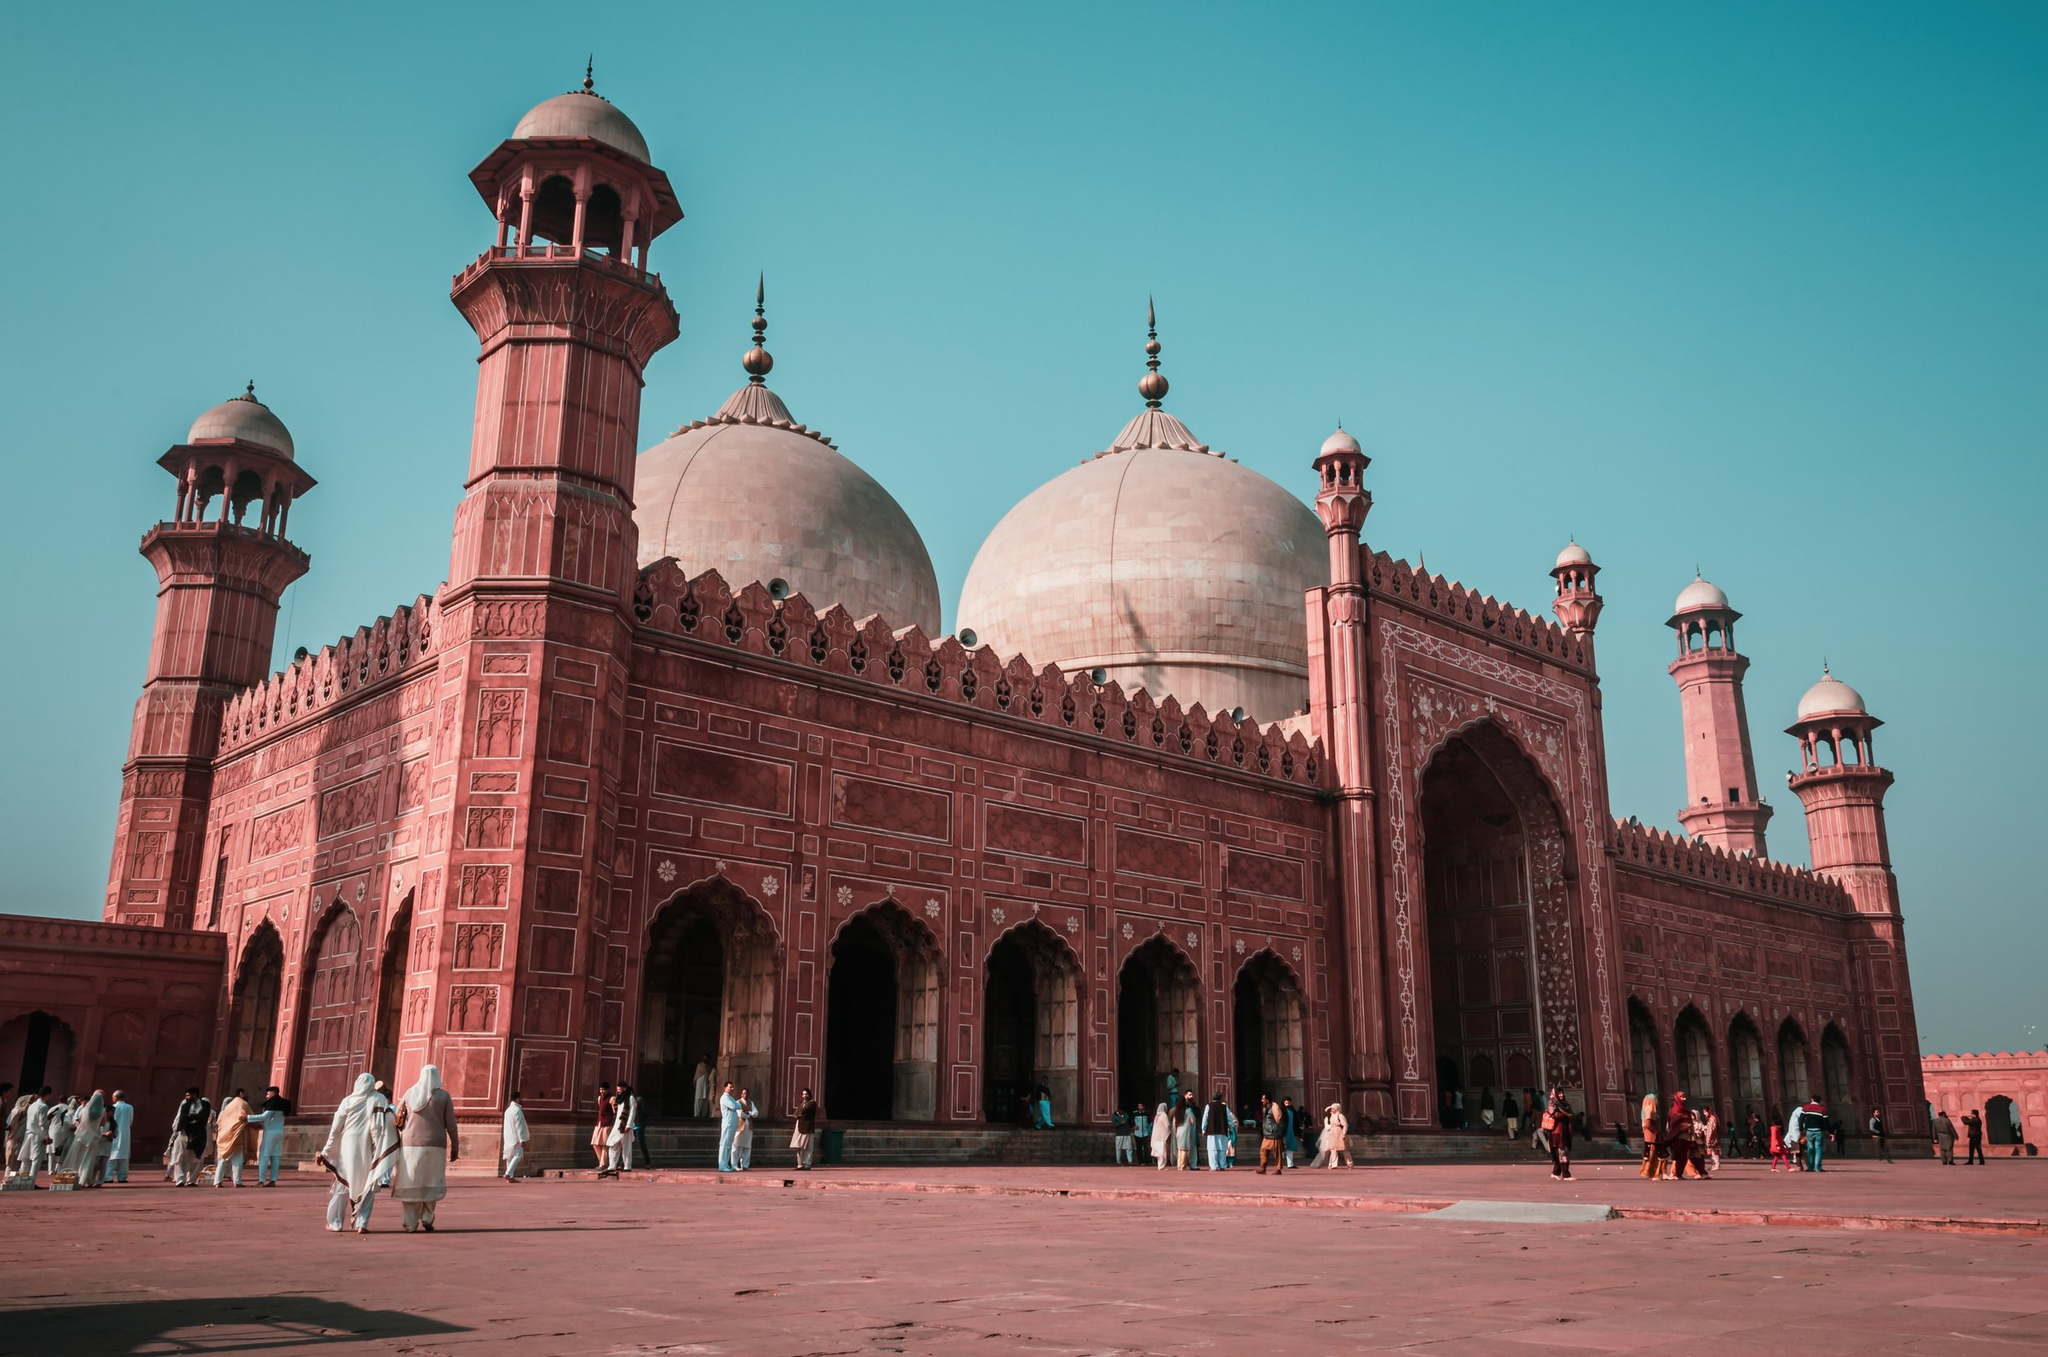Describe a long realistic scenario about what might be happening in this image. The image portrays a typical day at the Badshahi Mosque, where a diverse group of visitors and worshippers has gathered. In the early morning, the mosque comes to life with the call to prayer, bringing a stream of devotees entering the courtyard, ready to begin their day with spiritual practice. Families and friends explore the vast courtyard, taking in the mosque’s architectural beauty and snapping memories with their cameras. Among the crowd, a school group is seen attentively listening to their teacher, who is narrating the rich history and cultural significance of the mosque. A photographer is carefully setting up his camera to capture the mosque in the golden hour, hoping to get the perfect shot. Vendors nearby are selling traditional refreshments, providing a taste of local culture to the visitors. Children play around, their laughter adding a lively soundtrack to the serene environment. As the afternoon progresses, some visitors find a quiet corner to sit and reflect, appreciating the tranquility amidst the hustle and bustle. The day closes with the evening prayer, and as the sun sets, the mosque is bathed in a warm, golden glow, bringing a magical end to the day’s activities. 